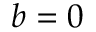Convert formula to latex. <formula><loc_0><loc_0><loc_500><loc_500>b = 0</formula> 